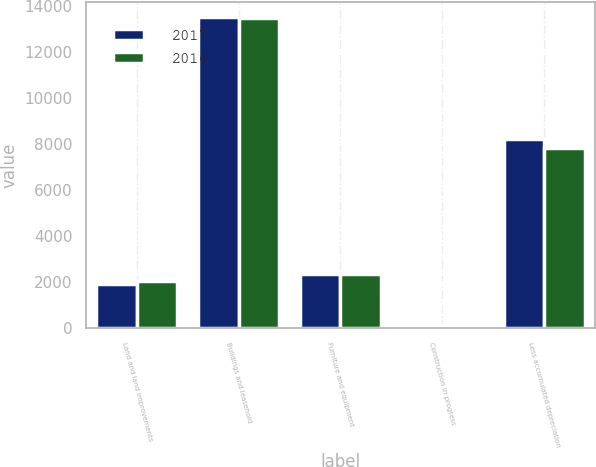<chart> <loc_0><loc_0><loc_500><loc_500><stacked_bar_chart><ecel><fcel>Land and land improvements<fcel>Buildings and leasehold<fcel>Furniture and equipment<fcel>Construction in progress<fcel>Less accumulated depreciation<nl><fcel>2017<fcel>1934<fcel>13529<fcel>2357<fcel>106<fcel>8234<nl><fcel>2016<fcel>2047<fcel>13483<fcel>2377<fcel>86<fcel>7848<nl></chart> 